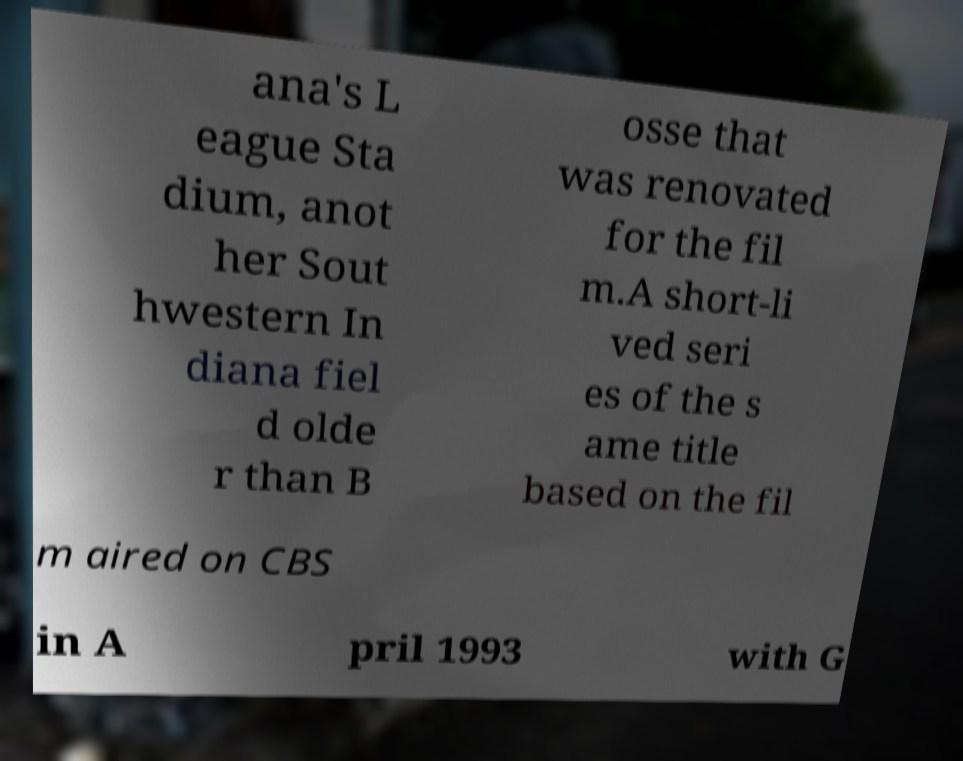Please read and relay the text visible in this image. What does it say? ana's L eague Sta dium, anot her Sout hwestern In diana fiel d olde r than B osse that was renovated for the fil m.A short-li ved seri es of the s ame title based on the fil m aired on CBS in A pril 1993 with G 